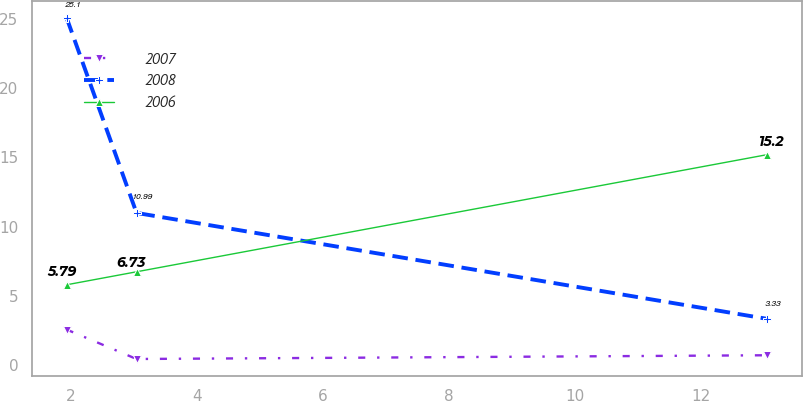Convert chart. <chart><loc_0><loc_0><loc_500><loc_500><line_chart><ecel><fcel>2007<fcel>2008<fcel>2006<nl><fcel>1.93<fcel>2.55<fcel>25.1<fcel>5.79<nl><fcel>3.04<fcel>0.42<fcel>10.99<fcel>6.73<nl><fcel>13.05<fcel>0.69<fcel>3.33<fcel>15.2<nl></chart> 